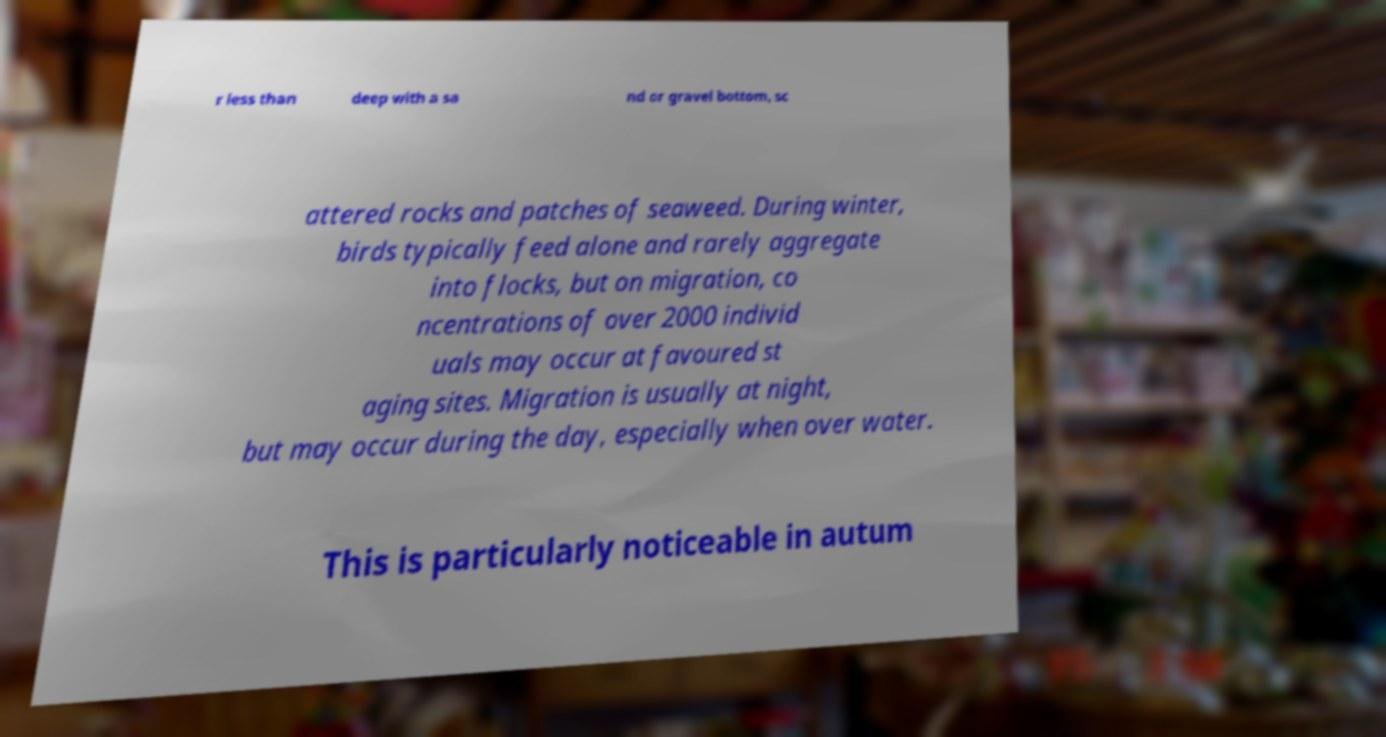Could you assist in decoding the text presented in this image and type it out clearly? r less than deep with a sa nd or gravel bottom, sc attered rocks and patches of seaweed. During winter, birds typically feed alone and rarely aggregate into flocks, but on migration, co ncentrations of over 2000 individ uals may occur at favoured st aging sites. Migration is usually at night, but may occur during the day, especially when over water. This is particularly noticeable in autum 